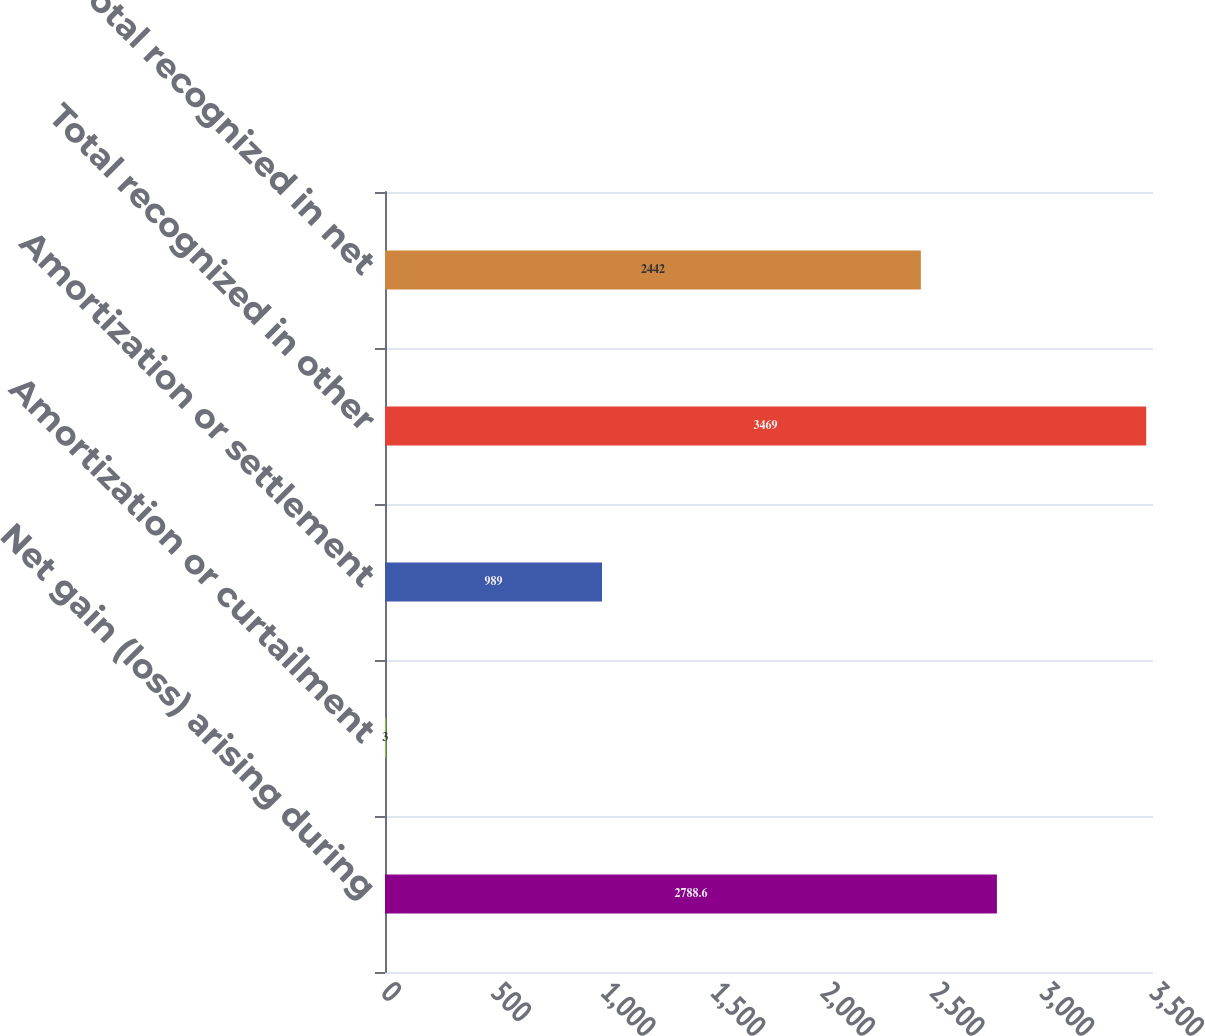Convert chart to OTSL. <chart><loc_0><loc_0><loc_500><loc_500><bar_chart><fcel>Net gain (loss) arising during<fcel>Amortization or curtailment<fcel>Amortization or settlement<fcel>Total recognized in other<fcel>Total recognized in net<nl><fcel>2788.6<fcel>3<fcel>989<fcel>3469<fcel>2442<nl></chart> 